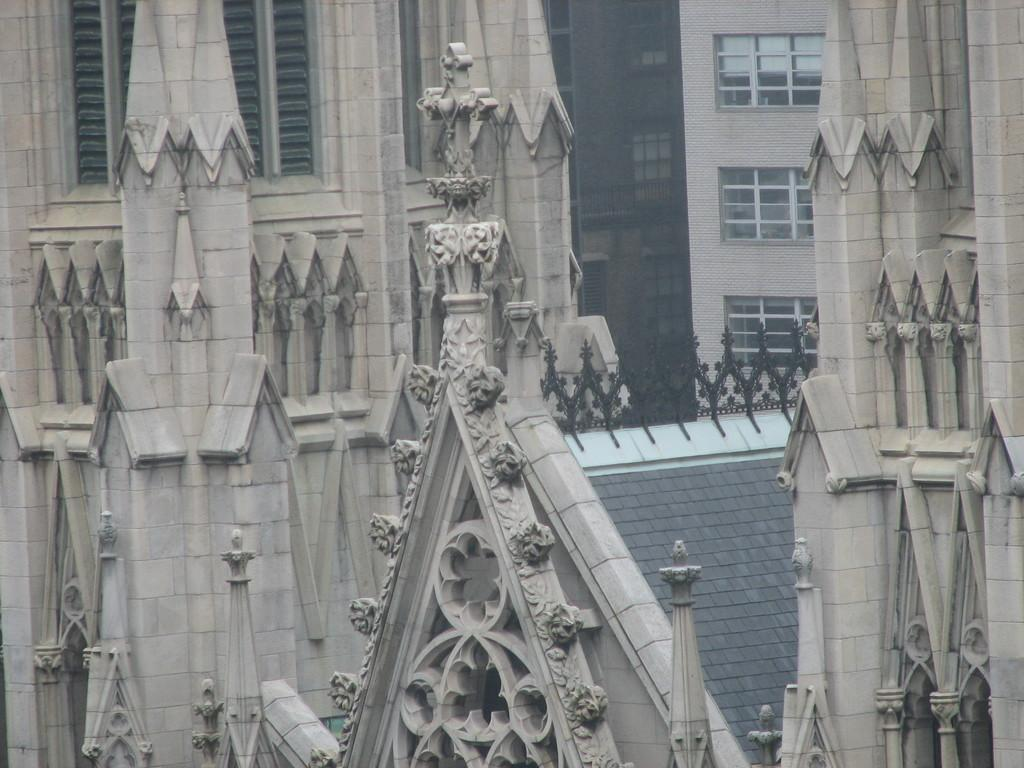What type of structures are present in the image? There are buildings in the image. What feature can be seen on the buildings? The buildings have windows. How many basketballs can be seen on the roof of the buildings in the image? There are no basketballs present in the image, and the roofs of the buildings are not visible. 